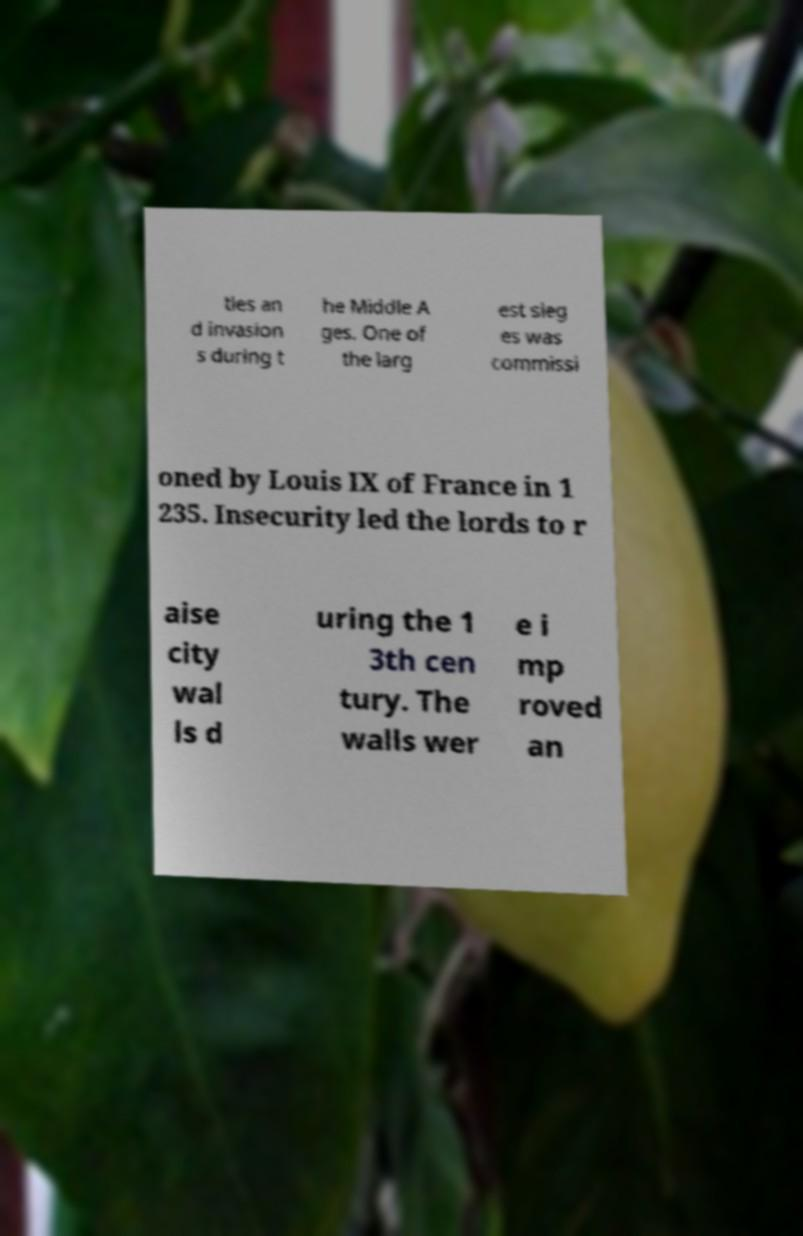Can you accurately transcribe the text from the provided image for me? tles an d invasion s during t he Middle A ges. One of the larg est sieg es was commissi oned by Louis IX of France in 1 235. Insecurity led the lords to r aise city wal ls d uring the 1 3th cen tury. The walls wer e i mp roved an 